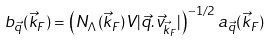<formula> <loc_0><loc_0><loc_500><loc_500>b _ { \vec { q } } ( \vec { k } _ { F } ) = \left ( N _ { \Lambda } ( \vec { k } _ { F } ) V | \vec { q } . \vec { v } _ { \vec { k } _ { F } } | \right ) ^ { - 1 / 2 } a _ { \vec { q } } ( \vec { k } _ { F } )</formula> 